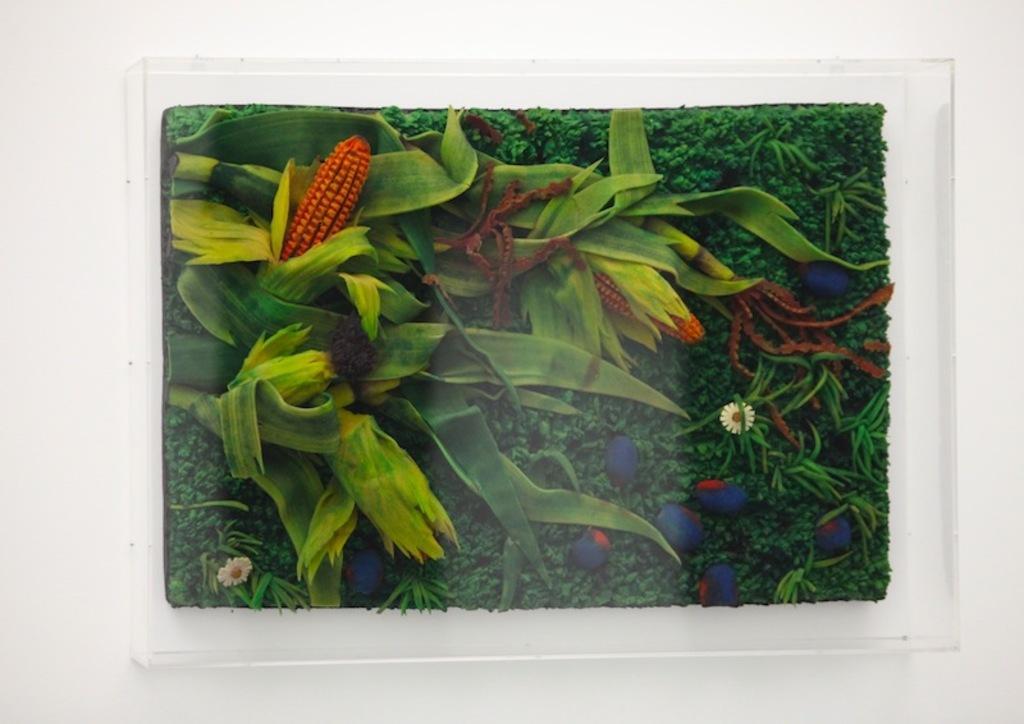How would you summarize this image in a sentence or two? In this image we can see a painting which is placed on a wall. In the painting we can see few plants, pebbles, fruits and flowers. 